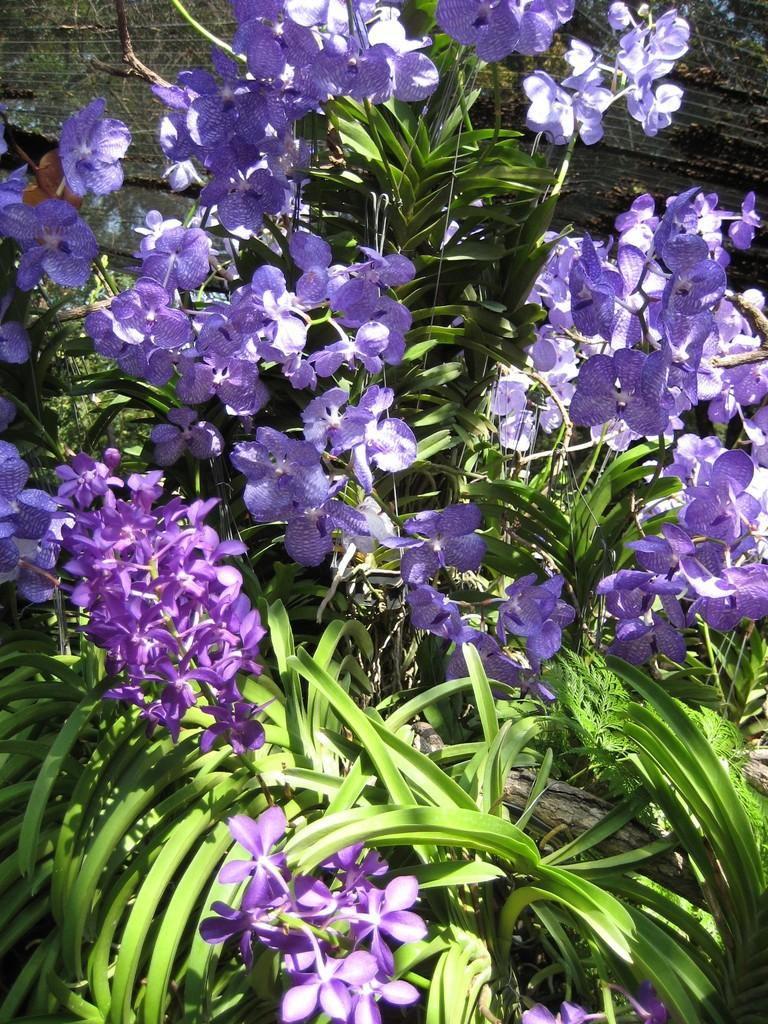What type of living organisms can be seen in the image? Plants and flowers are visible in the image. Can you describe the flowers in the image? The flowers are part of the plants that are present in the image. What is visible in the background of the image? There is a wall in the background of the image. How many pigs are connected to the plants in the image? There are no pigs present in the image, and therefore no connection to the plants can be observed. 